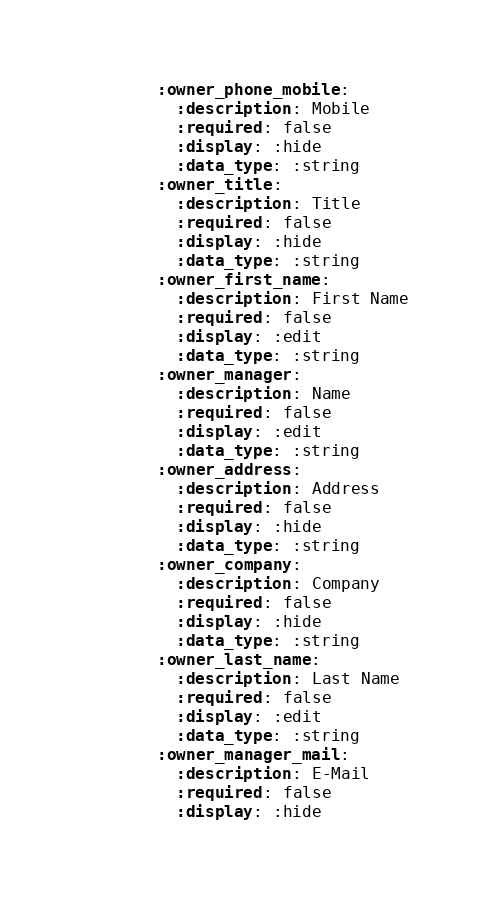<code> <loc_0><loc_0><loc_500><loc_500><_YAML_>        :owner_phone_mobile:
          :description: Mobile
          :required: false
          :display: :hide
          :data_type: :string
        :owner_title:
          :description: Title
          :required: false
          :display: :hide
          :data_type: :string
        :owner_first_name:
          :description: First Name
          :required: false
          :display: :edit
          :data_type: :string
        :owner_manager:
          :description: Name
          :required: false
          :display: :edit
          :data_type: :string
        :owner_address:
          :description: Address
          :required: false
          :display: :hide
          :data_type: :string
        :owner_company:
          :description: Company
          :required: false
          :display: :hide
          :data_type: :string
        :owner_last_name:
          :description: Last Name
          :required: false
          :display: :edit
          :data_type: :string
        :owner_manager_mail:
          :description: E-Mail
          :required: false
          :display: :hide</code> 